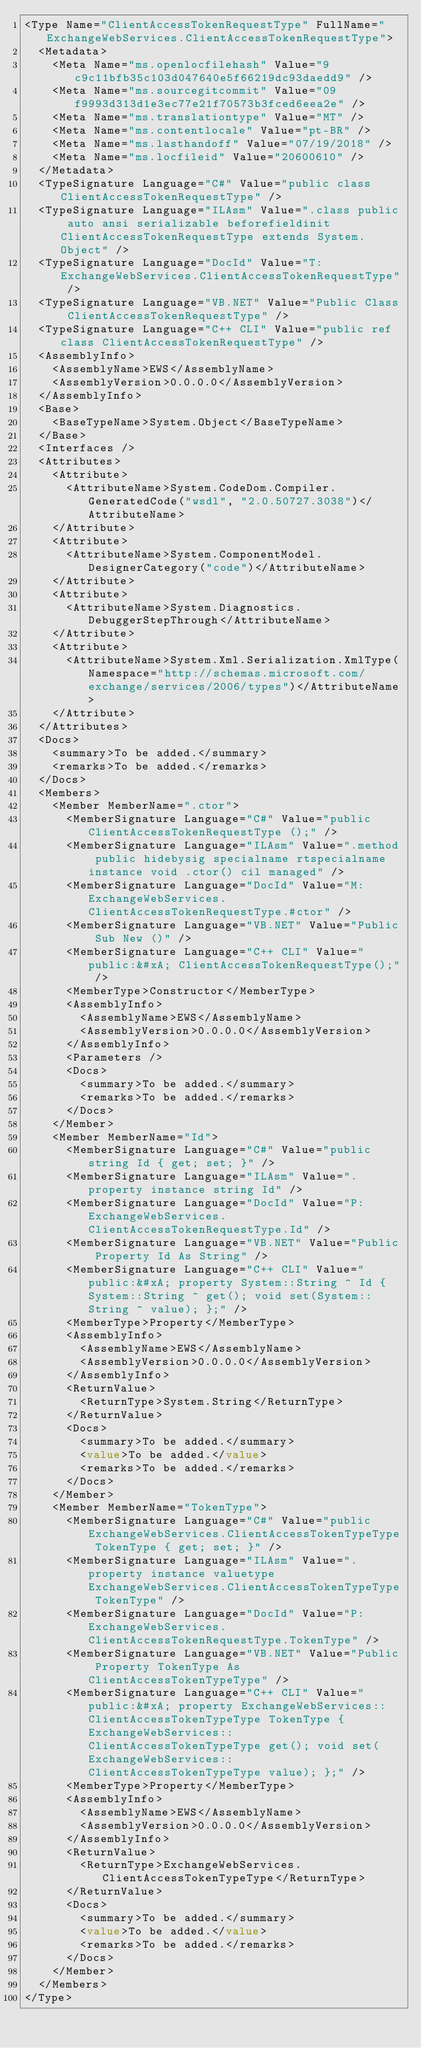Convert code to text. <code><loc_0><loc_0><loc_500><loc_500><_XML_><Type Name="ClientAccessTokenRequestType" FullName="ExchangeWebServices.ClientAccessTokenRequestType">
  <Metadata>
    <Meta Name="ms.openlocfilehash" Value="9c9c11bfb35c103d047640e5f66219dc93daedd9" />
    <Meta Name="ms.sourcegitcommit" Value="09f9993d313d1e3ec77e21f70573b3fced6eea2e" />
    <Meta Name="ms.translationtype" Value="MT" />
    <Meta Name="ms.contentlocale" Value="pt-BR" />
    <Meta Name="ms.lasthandoff" Value="07/19/2018" />
    <Meta Name="ms.locfileid" Value="20600610" />
  </Metadata>
  <TypeSignature Language="C#" Value="public class ClientAccessTokenRequestType" />
  <TypeSignature Language="ILAsm" Value=".class public auto ansi serializable beforefieldinit ClientAccessTokenRequestType extends System.Object" />
  <TypeSignature Language="DocId" Value="T:ExchangeWebServices.ClientAccessTokenRequestType" />
  <TypeSignature Language="VB.NET" Value="Public Class ClientAccessTokenRequestType" />
  <TypeSignature Language="C++ CLI" Value="public ref class ClientAccessTokenRequestType" />
  <AssemblyInfo>
    <AssemblyName>EWS</AssemblyName>
    <AssemblyVersion>0.0.0.0</AssemblyVersion>
  </AssemblyInfo>
  <Base>
    <BaseTypeName>System.Object</BaseTypeName>
  </Base>
  <Interfaces />
  <Attributes>
    <Attribute>
      <AttributeName>System.CodeDom.Compiler.GeneratedCode("wsdl", "2.0.50727.3038")</AttributeName>
    </Attribute>
    <Attribute>
      <AttributeName>System.ComponentModel.DesignerCategory("code")</AttributeName>
    </Attribute>
    <Attribute>
      <AttributeName>System.Diagnostics.DebuggerStepThrough</AttributeName>
    </Attribute>
    <Attribute>
      <AttributeName>System.Xml.Serialization.XmlType(Namespace="http://schemas.microsoft.com/exchange/services/2006/types")</AttributeName>
    </Attribute>
  </Attributes>
  <Docs>
    <summary>To be added.</summary>
    <remarks>To be added.</remarks>
  </Docs>
  <Members>
    <Member MemberName=".ctor">
      <MemberSignature Language="C#" Value="public ClientAccessTokenRequestType ();" />
      <MemberSignature Language="ILAsm" Value=".method public hidebysig specialname rtspecialname instance void .ctor() cil managed" />
      <MemberSignature Language="DocId" Value="M:ExchangeWebServices.ClientAccessTokenRequestType.#ctor" />
      <MemberSignature Language="VB.NET" Value="Public Sub New ()" />
      <MemberSignature Language="C++ CLI" Value="public:&#xA; ClientAccessTokenRequestType();" />
      <MemberType>Constructor</MemberType>
      <AssemblyInfo>
        <AssemblyName>EWS</AssemblyName>
        <AssemblyVersion>0.0.0.0</AssemblyVersion>
      </AssemblyInfo>
      <Parameters />
      <Docs>
        <summary>To be added.</summary>
        <remarks>To be added.</remarks>
      </Docs>
    </Member>
    <Member MemberName="Id">
      <MemberSignature Language="C#" Value="public string Id { get; set; }" />
      <MemberSignature Language="ILAsm" Value=".property instance string Id" />
      <MemberSignature Language="DocId" Value="P:ExchangeWebServices.ClientAccessTokenRequestType.Id" />
      <MemberSignature Language="VB.NET" Value="Public Property Id As String" />
      <MemberSignature Language="C++ CLI" Value="public:&#xA; property System::String ^ Id { System::String ^ get(); void set(System::String ^ value); };" />
      <MemberType>Property</MemberType>
      <AssemblyInfo>
        <AssemblyName>EWS</AssemblyName>
        <AssemblyVersion>0.0.0.0</AssemblyVersion>
      </AssemblyInfo>
      <ReturnValue>
        <ReturnType>System.String</ReturnType>
      </ReturnValue>
      <Docs>
        <summary>To be added.</summary>
        <value>To be added.</value>
        <remarks>To be added.</remarks>
      </Docs>
    </Member>
    <Member MemberName="TokenType">
      <MemberSignature Language="C#" Value="public ExchangeWebServices.ClientAccessTokenTypeType TokenType { get; set; }" />
      <MemberSignature Language="ILAsm" Value=".property instance valuetype ExchangeWebServices.ClientAccessTokenTypeType TokenType" />
      <MemberSignature Language="DocId" Value="P:ExchangeWebServices.ClientAccessTokenRequestType.TokenType" />
      <MemberSignature Language="VB.NET" Value="Public Property TokenType As ClientAccessTokenTypeType" />
      <MemberSignature Language="C++ CLI" Value="public:&#xA; property ExchangeWebServices::ClientAccessTokenTypeType TokenType { ExchangeWebServices::ClientAccessTokenTypeType get(); void set(ExchangeWebServices::ClientAccessTokenTypeType value); };" />
      <MemberType>Property</MemberType>
      <AssemblyInfo>
        <AssemblyName>EWS</AssemblyName>
        <AssemblyVersion>0.0.0.0</AssemblyVersion>
      </AssemblyInfo>
      <ReturnValue>
        <ReturnType>ExchangeWebServices.ClientAccessTokenTypeType</ReturnType>
      </ReturnValue>
      <Docs>
        <summary>To be added.</summary>
        <value>To be added.</value>
        <remarks>To be added.</remarks>
      </Docs>
    </Member>
  </Members>
</Type></code> 